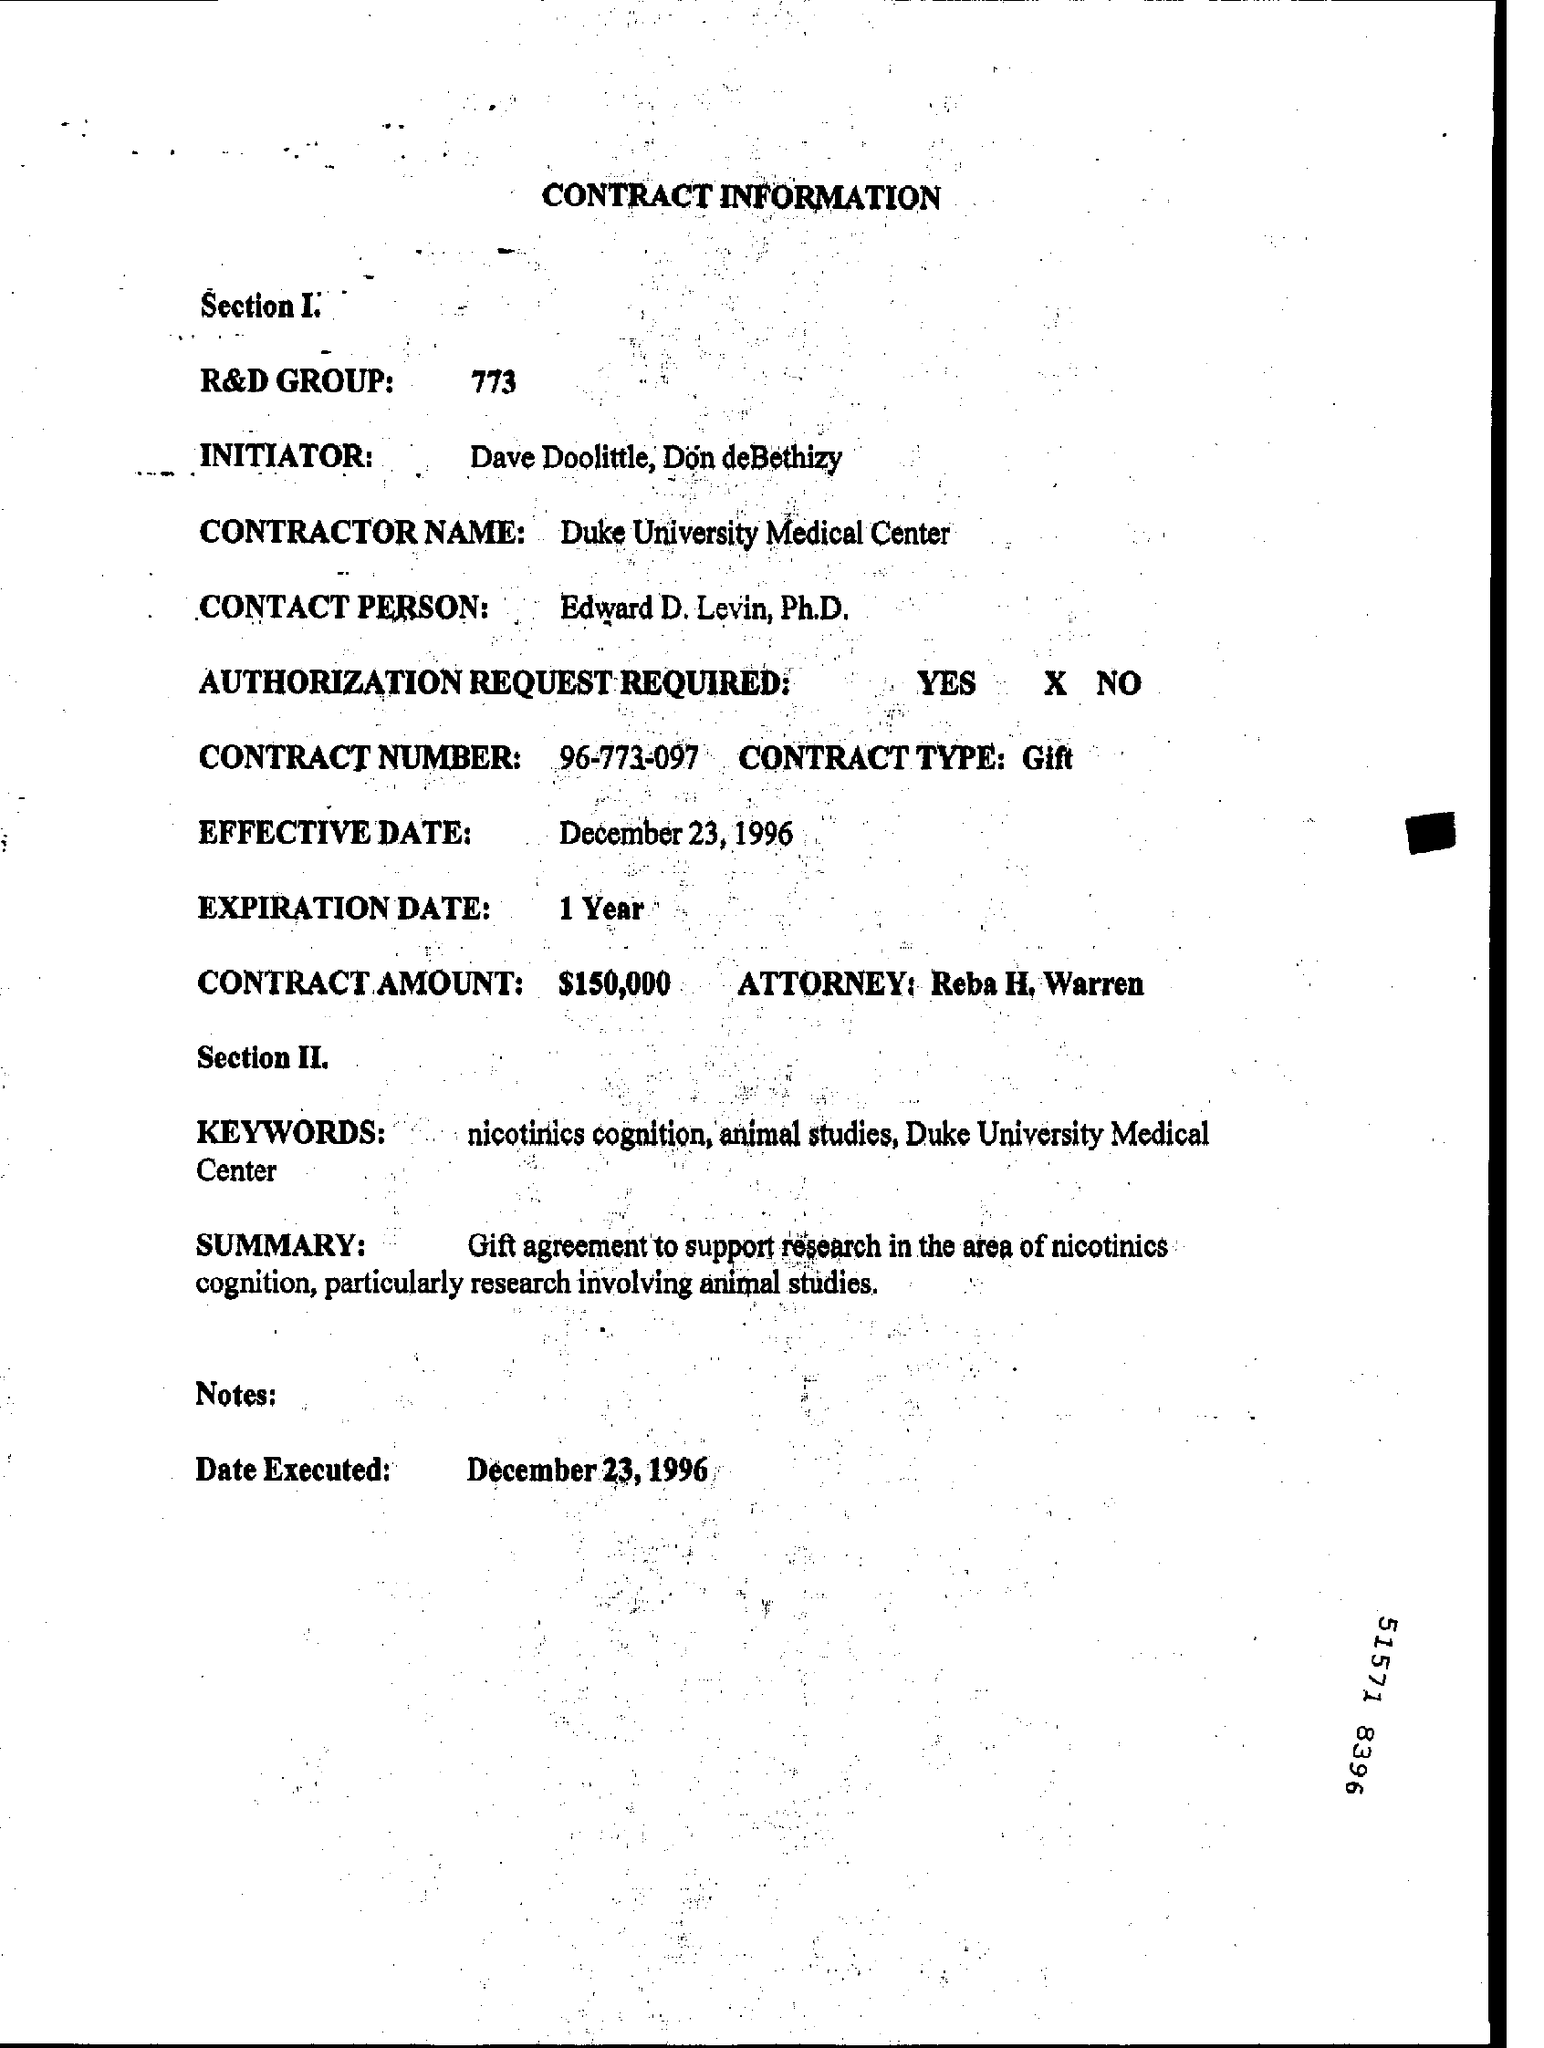Point out several critical features in this image. The contract number is 96-773-097... The name of the Attorney is Reba H. Warren. The expiration date is one year. Please provide the contact information for the R&D group, including the phone number. 